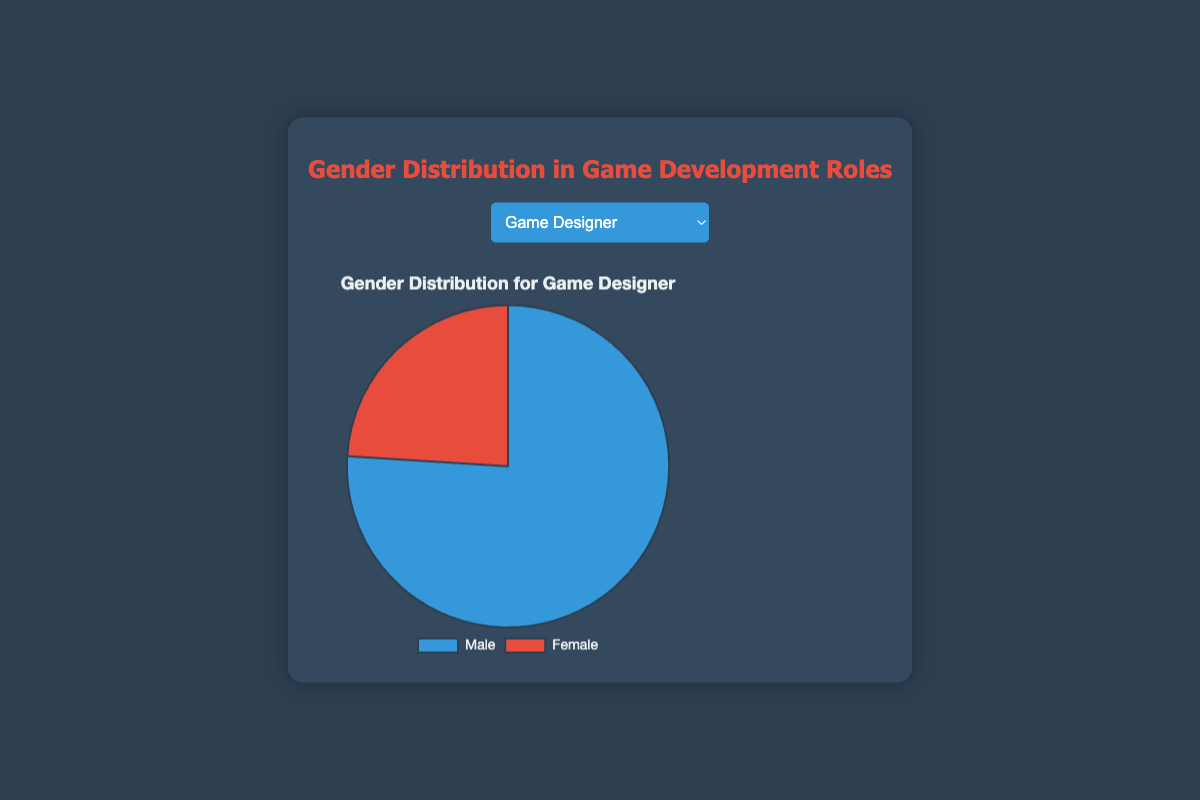What's the gender distribution for the role of Game Designer? The chart will show a pie divided into two segments. For the Game Designer role, 76% is labeled as Male and 24% as Female.
Answer: 76% Male, 24% Female Which role has the highest percentage of females? By viewing all roles' pie charts, the Writer role has the highest female representation at 46%.
Answer: Writer Which role has the closest gender balance? By looking at the pie charts, the Writer role has the closest distribution with 54% Male and 46% Female.
Answer: Writer How does the gender distribution of Programmers compare to that of Artists? Comparatively, the Programmer role has 88% Male and 12% Female, while the Artist role has 67% Male and 33% Female.
Answer: Programmers: 88% Male, 12% Female; Artists: 67% Male, 33% Female What is the difference in percentage points between Male and Female Producers? From the pie chart for producers, there are 63% Males and 37% Females. The difference is 63% - 37% = 26%.
Answer: 26% Which role has the greatest disparity between genders? By comparing the pie charts, the Programmer role shows the greatest disparity with 88% Male and 12% Female, making a 76% difference.
Answer: Programmer What is the combined percentage of females in Game Designer and Quality Assurance Tester roles? The pie charts for Game Designer shows 24% Female, and for Quality Assurance Tester, it shows 30% Female. Combining these, 24% + 30% = 54%.
Answer: 54% Which role has more than twice the percentage of males compared to females? Evaluating each role, Programmer (88% Male, 12% Female), Game Designer (76% Male, 24% Female), and Audio Engineer (84% Male, 16% Female) fit this criterion as their male percentage is more than twice the female percentage.
Answer: Programmer, Game Designer, Audio Engineer Are there any roles where females outnumber males? By examining all the pie charts, none of the roles have a higher percentage of females compared to males.
Answer: None 